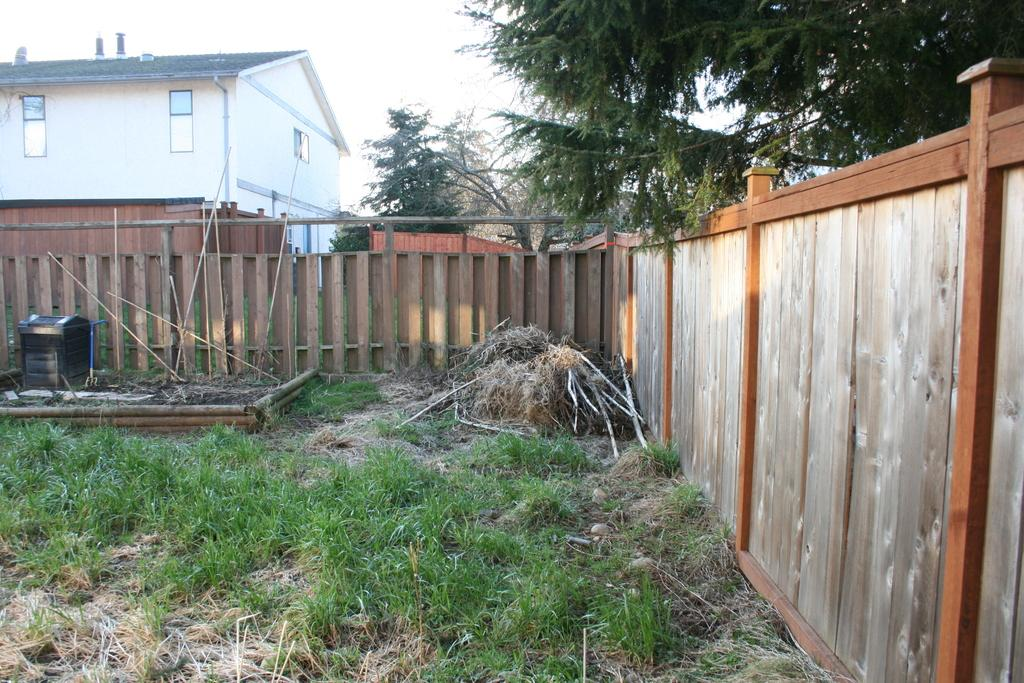What type of vegetation is present in the image? There is grass in the image. What structure can be seen in the image? There is a fence in the image. What can be seen in the distance in the image? There is a house and trees in the background of the image. What color is the crayon that your dad is holding in the image? There is no dad or crayon present in the image. How does the fog affect the visibility of the house in the background? There is no fog present in the image, so it does not affect the visibility of the house in the background. 